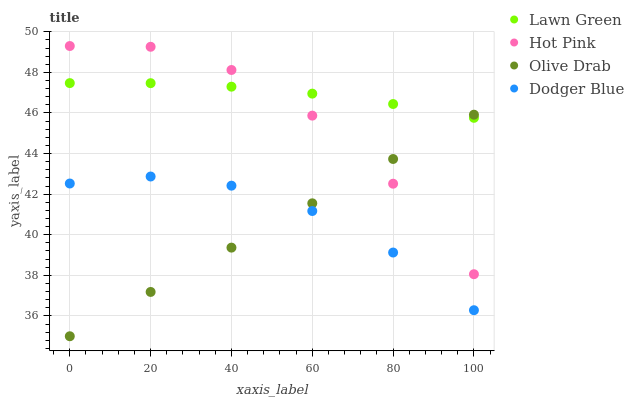Does Olive Drab have the minimum area under the curve?
Answer yes or no. Yes. Does Lawn Green have the maximum area under the curve?
Answer yes or no. Yes. Does Hot Pink have the minimum area under the curve?
Answer yes or no. No. Does Hot Pink have the maximum area under the curve?
Answer yes or no. No. Is Olive Drab the smoothest?
Answer yes or no. Yes. Is Hot Pink the roughest?
Answer yes or no. Yes. Is Dodger Blue the smoothest?
Answer yes or no. No. Is Dodger Blue the roughest?
Answer yes or no. No. Does Olive Drab have the lowest value?
Answer yes or no. Yes. Does Hot Pink have the lowest value?
Answer yes or no. No. Does Hot Pink have the highest value?
Answer yes or no. Yes. Does Dodger Blue have the highest value?
Answer yes or no. No. Is Dodger Blue less than Lawn Green?
Answer yes or no. Yes. Is Hot Pink greater than Dodger Blue?
Answer yes or no. Yes. Does Lawn Green intersect Hot Pink?
Answer yes or no. Yes. Is Lawn Green less than Hot Pink?
Answer yes or no. No. Is Lawn Green greater than Hot Pink?
Answer yes or no. No. Does Dodger Blue intersect Lawn Green?
Answer yes or no. No. 